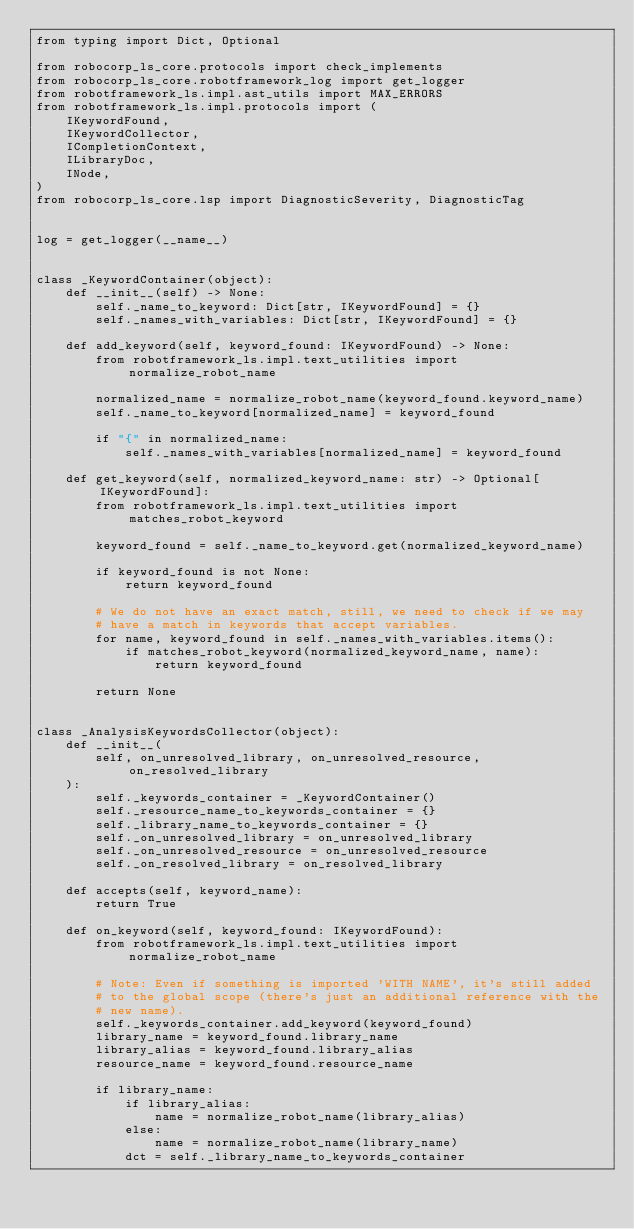<code> <loc_0><loc_0><loc_500><loc_500><_Python_>from typing import Dict, Optional

from robocorp_ls_core.protocols import check_implements
from robocorp_ls_core.robotframework_log import get_logger
from robotframework_ls.impl.ast_utils import MAX_ERRORS
from robotframework_ls.impl.protocols import (
    IKeywordFound,
    IKeywordCollector,
    ICompletionContext,
    ILibraryDoc,
    INode,
)
from robocorp_ls_core.lsp import DiagnosticSeverity, DiagnosticTag


log = get_logger(__name__)


class _KeywordContainer(object):
    def __init__(self) -> None:
        self._name_to_keyword: Dict[str, IKeywordFound] = {}
        self._names_with_variables: Dict[str, IKeywordFound] = {}

    def add_keyword(self, keyword_found: IKeywordFound) -> None:
        from robotframework_ls.impl.text_utilities import normalize_robot_name

        normalized_name = normalize_robot_name(keyword_found.keyword_name)
        self._name_to_keyword[normalized_name] = keyword_found

        if "{" in normalized_name:
            self._names_with_variables[normalized_name] = keyword_found

    def get_keyword(self, normalized_keyword_name: str) -> Optional[IKeywordFound]:
        from robotframework_ls.impl.text_utilities import matches_robot_keyword

        keyword_found = self._name_to_keyword.get(normalized_keyword_name)

        if keyword_found is not None:
            return keyword_found

        # We do not have an exact match, still, we need to check if we may
        # have a match in keywords that accept variables.
        for name, keyword_found in self._names_with_variables.items():
            if matches_robot_keyword(normalized_keyword_name, name):
                return keyword_found

        return None


class _AnalysisKeywordsCollector(object):
    def __init__(
        self, on_unresolved_library, on_unresolved_resource, on_resolved_library
    ):
        self._keywords_container = _KeywordContainer()
        self._resource_name_to_keywords_container = {}
        self._library_name_to_keywords_container = {}
        self._on_unresolved_library = on_unresolved_library
        self._on_unresolved_resource = on_unresolved_resource
        self._on_resolved_library = on_resolved_library

    def accepts(self, keyword_name):
        return True

    def on_keyword(self, keyword_found: IKeywordFound):
        from robotframework_ls.impl.text_utilities import normalize_robot_name

        # Note: Even if something is imported 'WITH NAME', it's still added
        # to the global scope (there's just an additional reference with the
        # new name).
        self._keywords_container.add_keyword(keyword_found)
        library_name = keyword_found.library_name
        library_alias = keyword_found.library_alias
        resource_name = keyword_found.resource_name

        if library_name:
            if library_alias:
                name = normalize_robot_name(library_alias)
            else:
                name = normalize_robot_name(library_name)
            dct = self._library_name_to_keywords_container</code> 